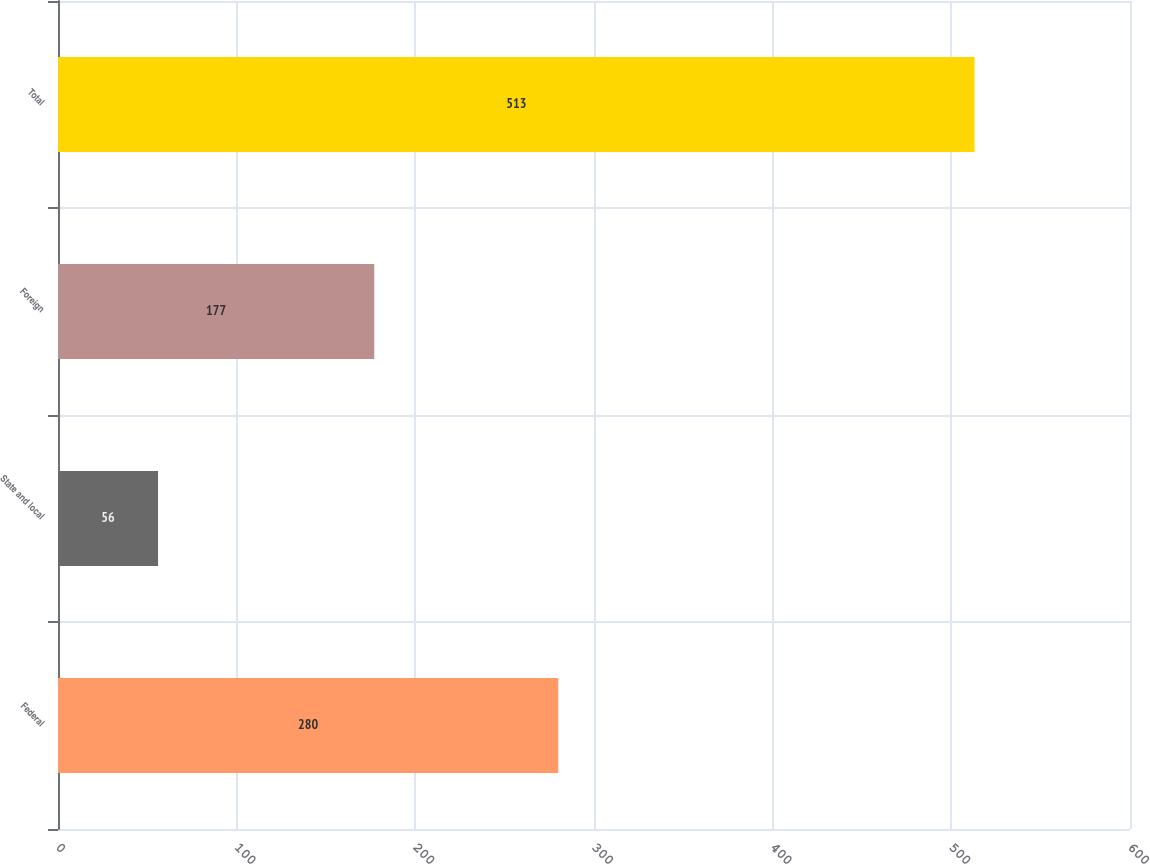Convert chart. <chart><loc_0><loc_0><loc_500><loc_500><bar_chart><fcel>Federal<fcel>State and local<fcel>Foreign<fcel>Total<nl><fcel>280<fcel>56<fcel>177<fcel>513<nl></chart> 